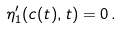<formula> <loc_0><loc_0><loc_500><loc_500>\eta _ { 1 } ^ { \prime } ( c ( t ) , t ) = 0 \, .</formula> 